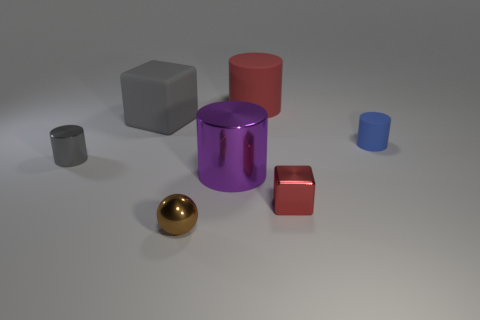Do the red cylinder and the gray rubber thing have the same size?
Offer a very short reply. Yes. How many other objects are the same size as the blue thing?
Keep it short and to the point. 3. Is the color of the large cube the same as the large metallic cylinder?
Your answer should be compact. No. There is a rubber object that is left of the red thing behind the gray object right of the small gray cylinder; what is its shape?
Your response must be concise. Cube. How many things are either large cylinders that are left of the big matte cylinder or shiny objects that are behind the red metal thing?
Provide a succinct answer. 2. What is the size of the metal thing on the left side of the gray thing that is on the right side of the tiny gray cylinder?
Ensure brevity in your answer.  Small. Is the color of the matte object left of the brown sphere the same as the sphere?
Give a very brief answer. No. Is there a purple metallic object that has the same shape as the large gray matte thing?
Keep it short and to the point. No. There is a metallic thing that is the same size as the rubber cube; what color is it?
Offer a very short reply. Purple. There is a cube behind the small gray cylinder; what is its size?
Ensure brevity in your answer.  Large. 